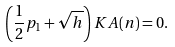<formula> <loc_0><loc_0><loc_500><loc_500>\left ( \frac { 1 } { 2 } p _ { 1 } + \sqrt { h } \right ) K A ( n ) = 0 .</formula> 